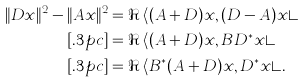<formula> <loc_0><loc_0><loc_500><loc_500>\| D x \| ^ { 2 } - \| A x \| ^ { 2 } & = \Re \, \langle ( A + D ) x , ( D - A ) x \rangle \\ [ . 3 p c ] & = \Re \, \langle ( A + D ) x , B D ^ { * } x \rangle \\ [ . 3 p c ] & = \Re \, \langle B ^ { * } ( A + D ) x , D ^ { * } x \rangle .</formula> 